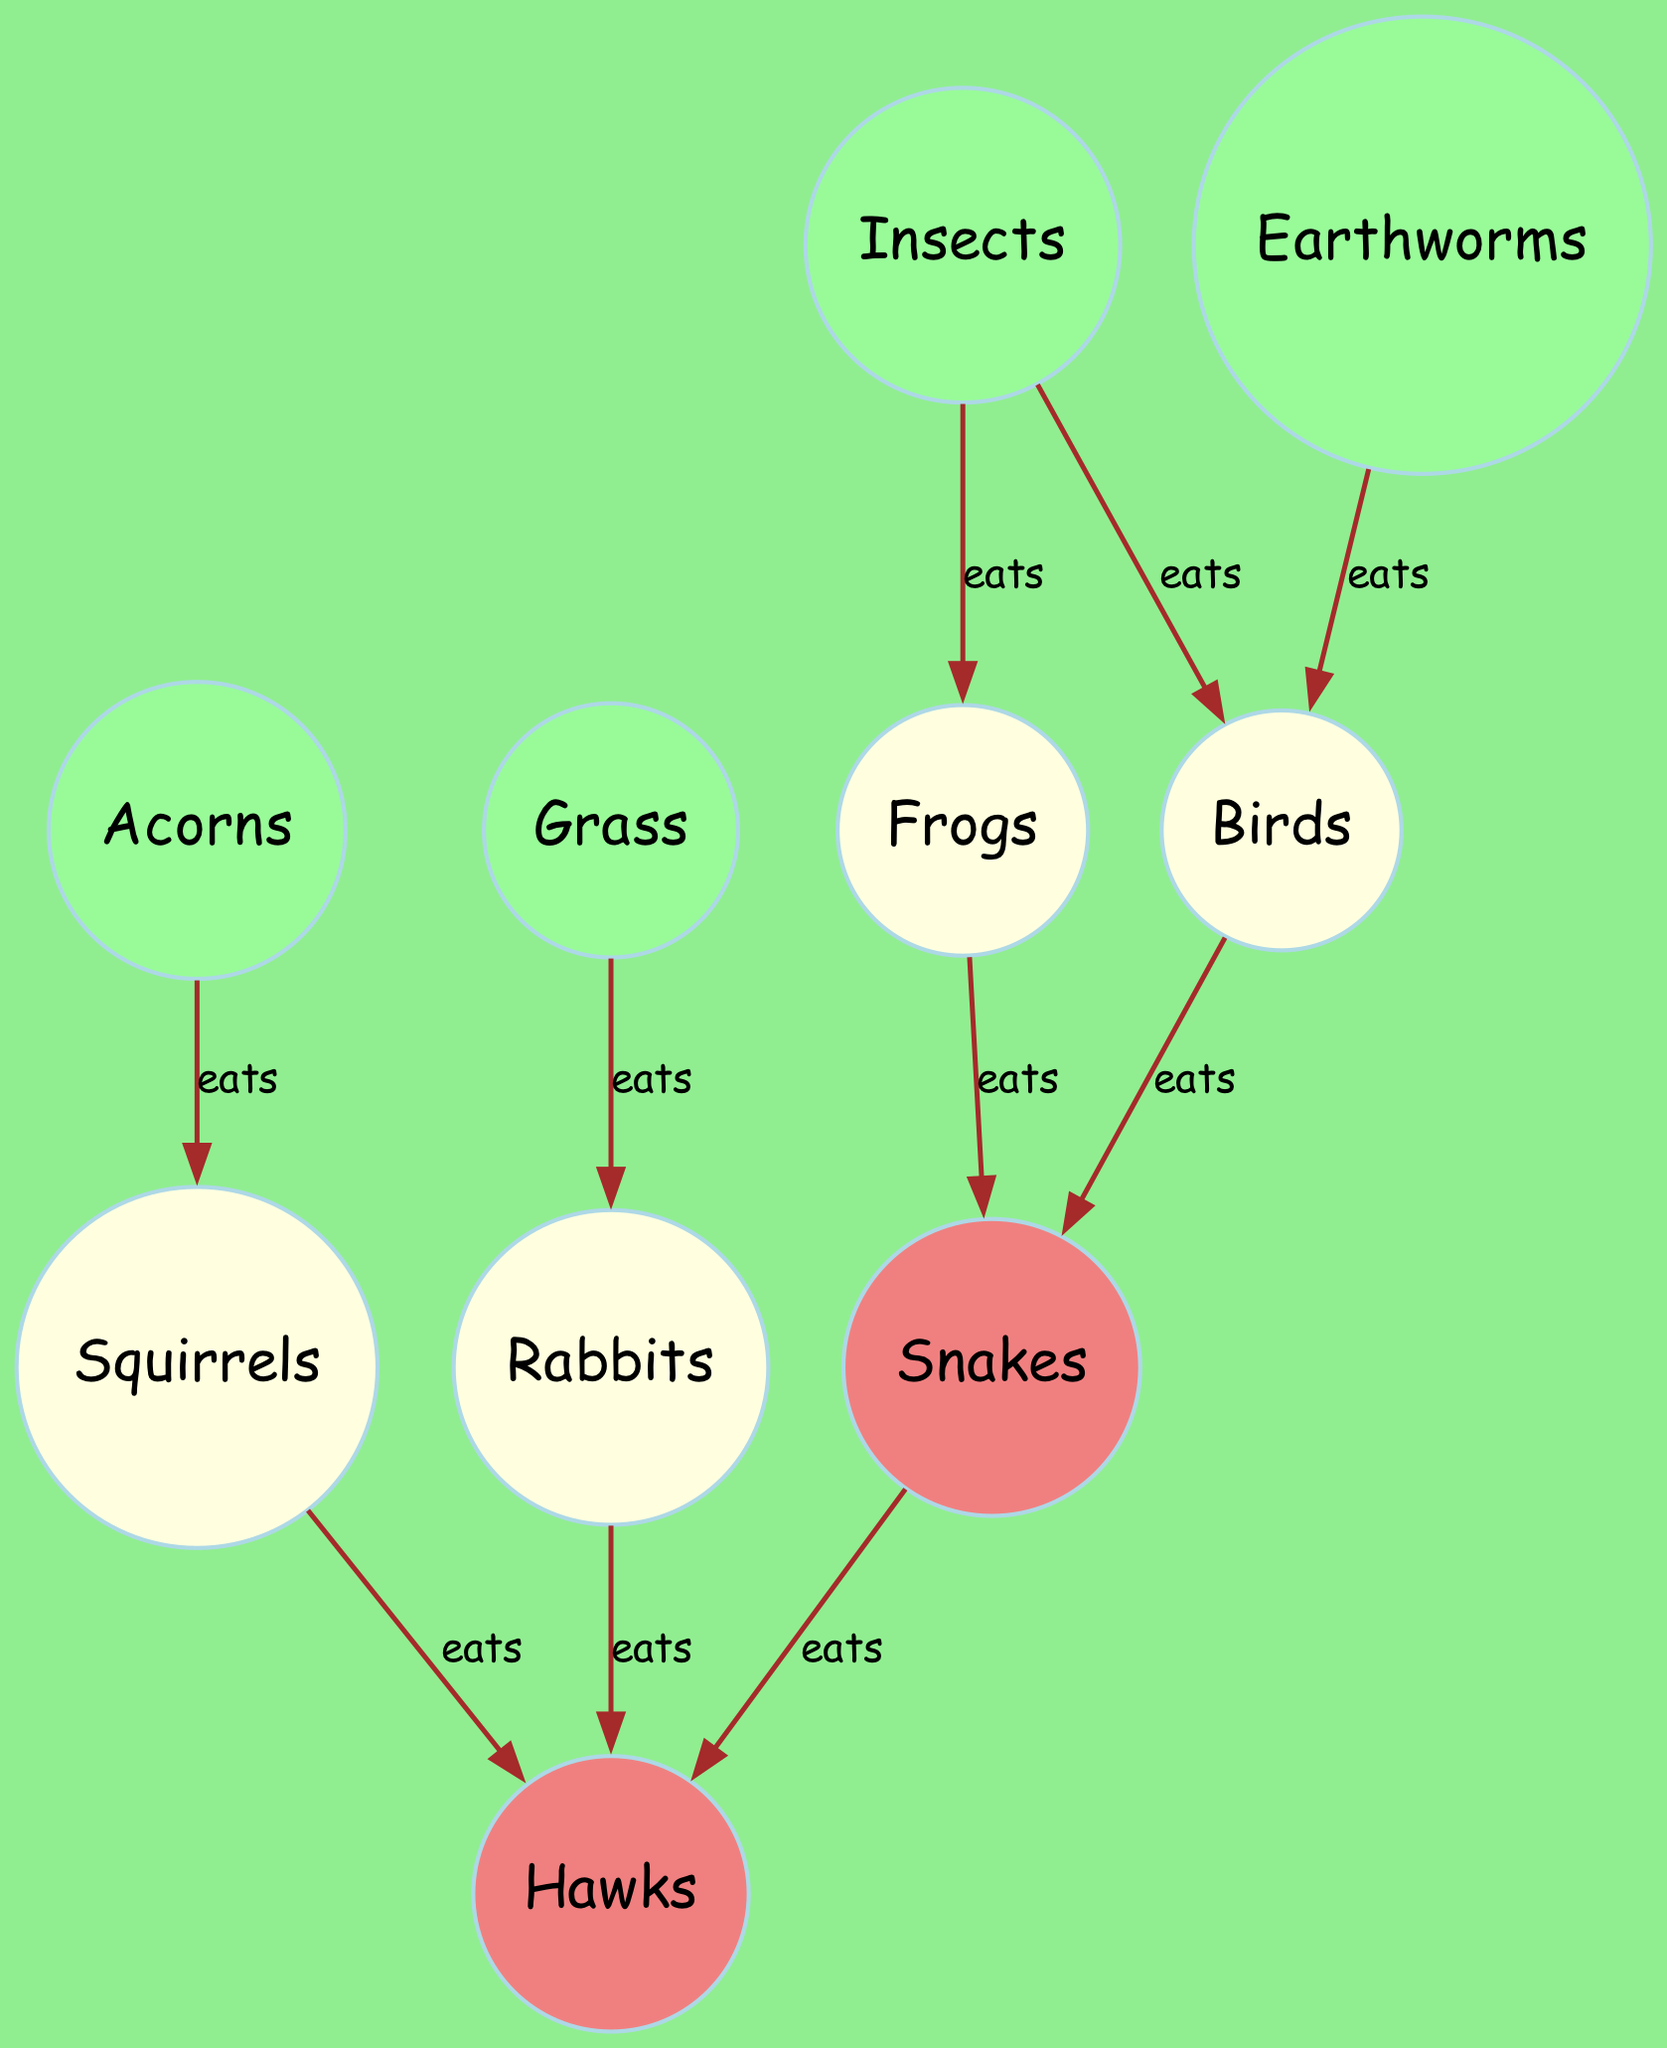What animal eats acorns? In the diagram, the edge between "Acorns" and "Squirrels" shows that Squirrels eat Acorns.
Answer: Squirrels How many plants are there in the diagram? The nodes representing plants are "Acorns," "Grass," "Insects," and "Earthworms." There are four nodes, so we count these to get the total number of plants.
Answer: 4 Which animal is at the top of the food chain? The directed edges leading from other animals to "Hawks" indicate that Hawks are the apex predators, meaning no other animals eat them.
Answer: Hawks Which two animals eat frogs? Looking at the edges connected to "Frogs," we find that "Snakes" and "Birds" both have directed edges leading to "Frogs," indicating that they eat Frogs.
Answer: Snakes, Birds How many edges can you find that indicate a predator-prey relationship? Each edge in the diagram represents a predator-prey relationship. Counting all the edges listed, there are ten instances shown.
Answer: 10 What do birds eat based on the diagram? The arrows from "Insects" and "Earthworms" to "Birds" indicate that both of these creatures are preyed on by Birds. Summarizing, I find the food sources shown directly linked to Birds.
Answer: Insects, Earthworms How many animals prey on rabbits? The diagram shows a directed edge from "Rabbits" to "Hawks," so only one animal is indicated as a predator of Rabbits according to the edges represented.
Answer: 1 Which two animals compete as predators in the park? Observing the edges, "Hawks" and "Snakes" both have directed edges leading to animals they eat, namely "Squirrels," "Rabbits," and "Frogs." This commonality shows that they share prey in the ecosystem context presented.
Answer: Hawks, Snakes 